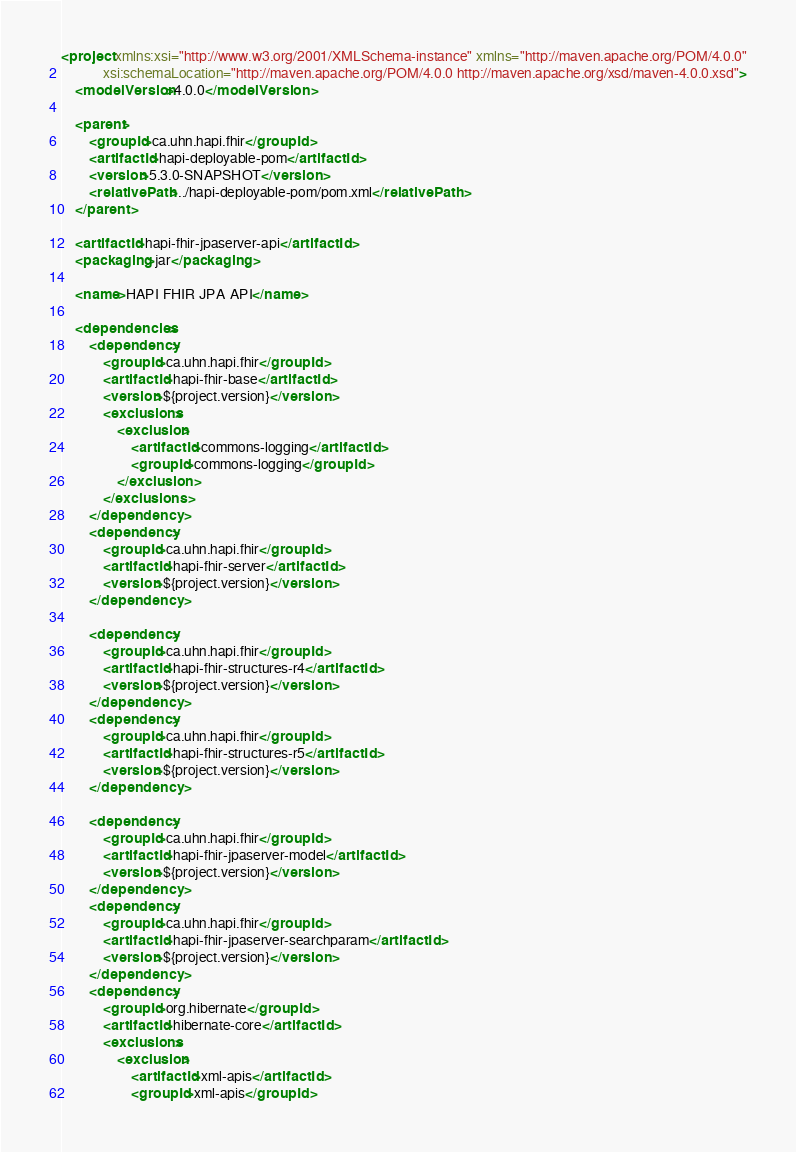Convert code to text. <code><loc_0><loc_0><loc_500><loc_500><_XML_><project xmlns:xsi="http://www.w3.org/2001/XMLSchema-instance" xmlns="http://maven.apache.org/POM/4.0.0"
			xsi:schemaLocation="http://maven.apache.org/POM/4.0.0 http://maven.apache.org/xsd/maven-4.0.0.xsd">
	<modelVersion>4.0.0</modelVersion>

	<parent>
		<groupId>ca.uhn.hapi.fhir</groupId>
		<artifactId>hapi-deployable-pom</artifactId>
		<version>5.3.0-SNAPSHOT</version>
		<relativePath>../hapi-deployable-pom/pom.xml</relativePath>
	</parent>

	<artifactId>hapi-fhir-jpaserver-api</artifactId>
	<packaging>jar</packaging>

	<name>HAPI FHIR JPA API</name>

	<dependencies>
		<dependency>
			<groupId>ca.uhn.hapi.fhir</groupId>
			<artifactId>hapi-fhir-base</artifactId>
			<version>${project.version}</version>
			<exclusions>
				<exclusion>
					<artifactId>commons-logging</artifactId>
					<groupId>commons-logging</groupId>
				</exclusion>
			</exclusions>
		</dependency>
		<dependency>
			<groupId>ca.uhn.hapi.fhir</groupId>
			<artifactId>hapi-fhir-server</artifactId>
			<version>${project.version}</version>
		</dependency>
		
		<dependency>
			<groupId>ca.uhn.hapi.fhir</groupId>
			<artifactId>hapi-fhir-structures-r4</artifactId>
			<version>${project.version}</version>
		</dependency>
		<dependency>
			<groupId>ca.uhn.hapi.fhir</groupId>
			<artifactId>hapi-fhir-structures-r5</artifactId>
			<version>${project.version}</version>
		</dependency>
		
        <dependency>
            <groupId>ca.uhn.hapi.fhir</groupId>
            <artifactId>hapi-fhir-jpaserver-model</artifactId>
            <version>${project.version}</version>
        </dependency>
        <dependency>
            <groupId>ca.uhn.hapi.fhir</groupId>
            <artifactId>hapi-fhir-jpaserver-searchparam</artifactId>
            <version>${project.version}</version>
        </dependency>
		<dependency>
			<groupId>org.hibernate</groupId>
			<artifactId>hibernate-core</artifactId>
			<exclusions>
				<exclusion>
					<artifactId>xml-apis</artifactId>
					<groupId>xml-apis</groupId></code> 